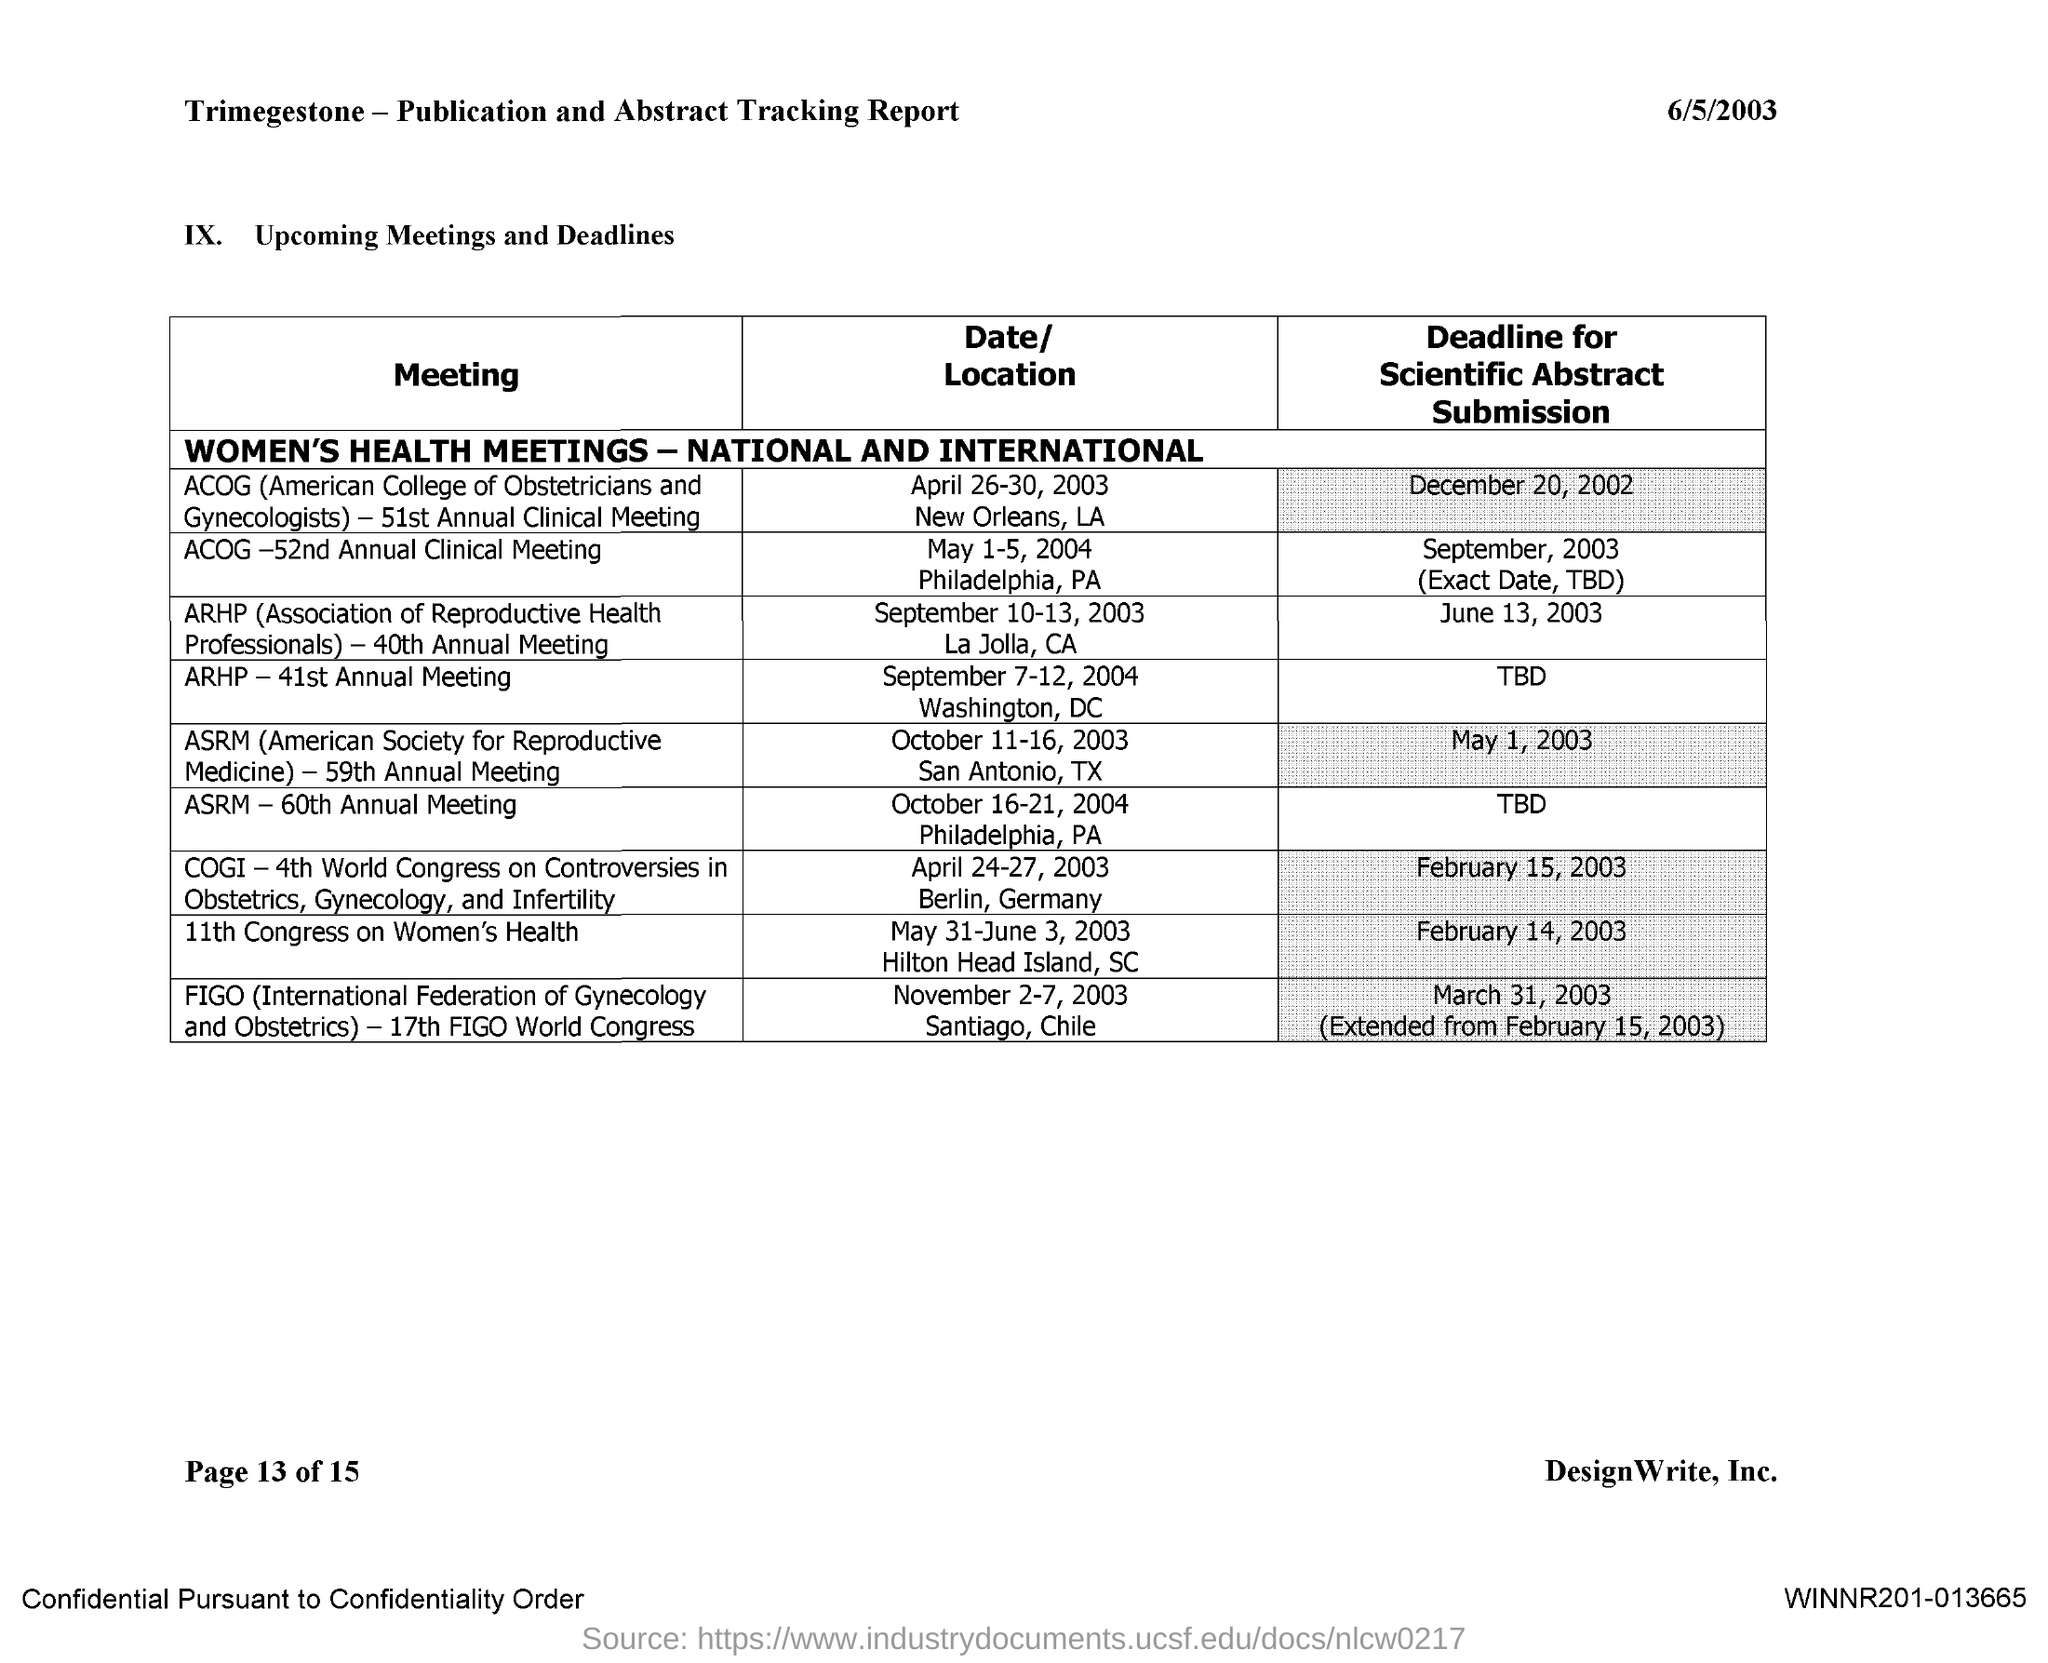What is the full form of ASRM?
Your answer should be very brief. American Society for Reproductive Medicine. 